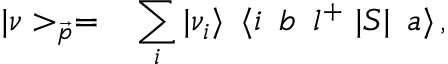Convert formula to latex. <formula><loc_0><loc_0><loc_500><loc_500>| \nu > _ { \vec { p } } = \, \sum _ { i } | \nu _ { i } \rangle \, \langle i \, b \, l ^ { + } | S | \, a \rangle \, ,</formula> 